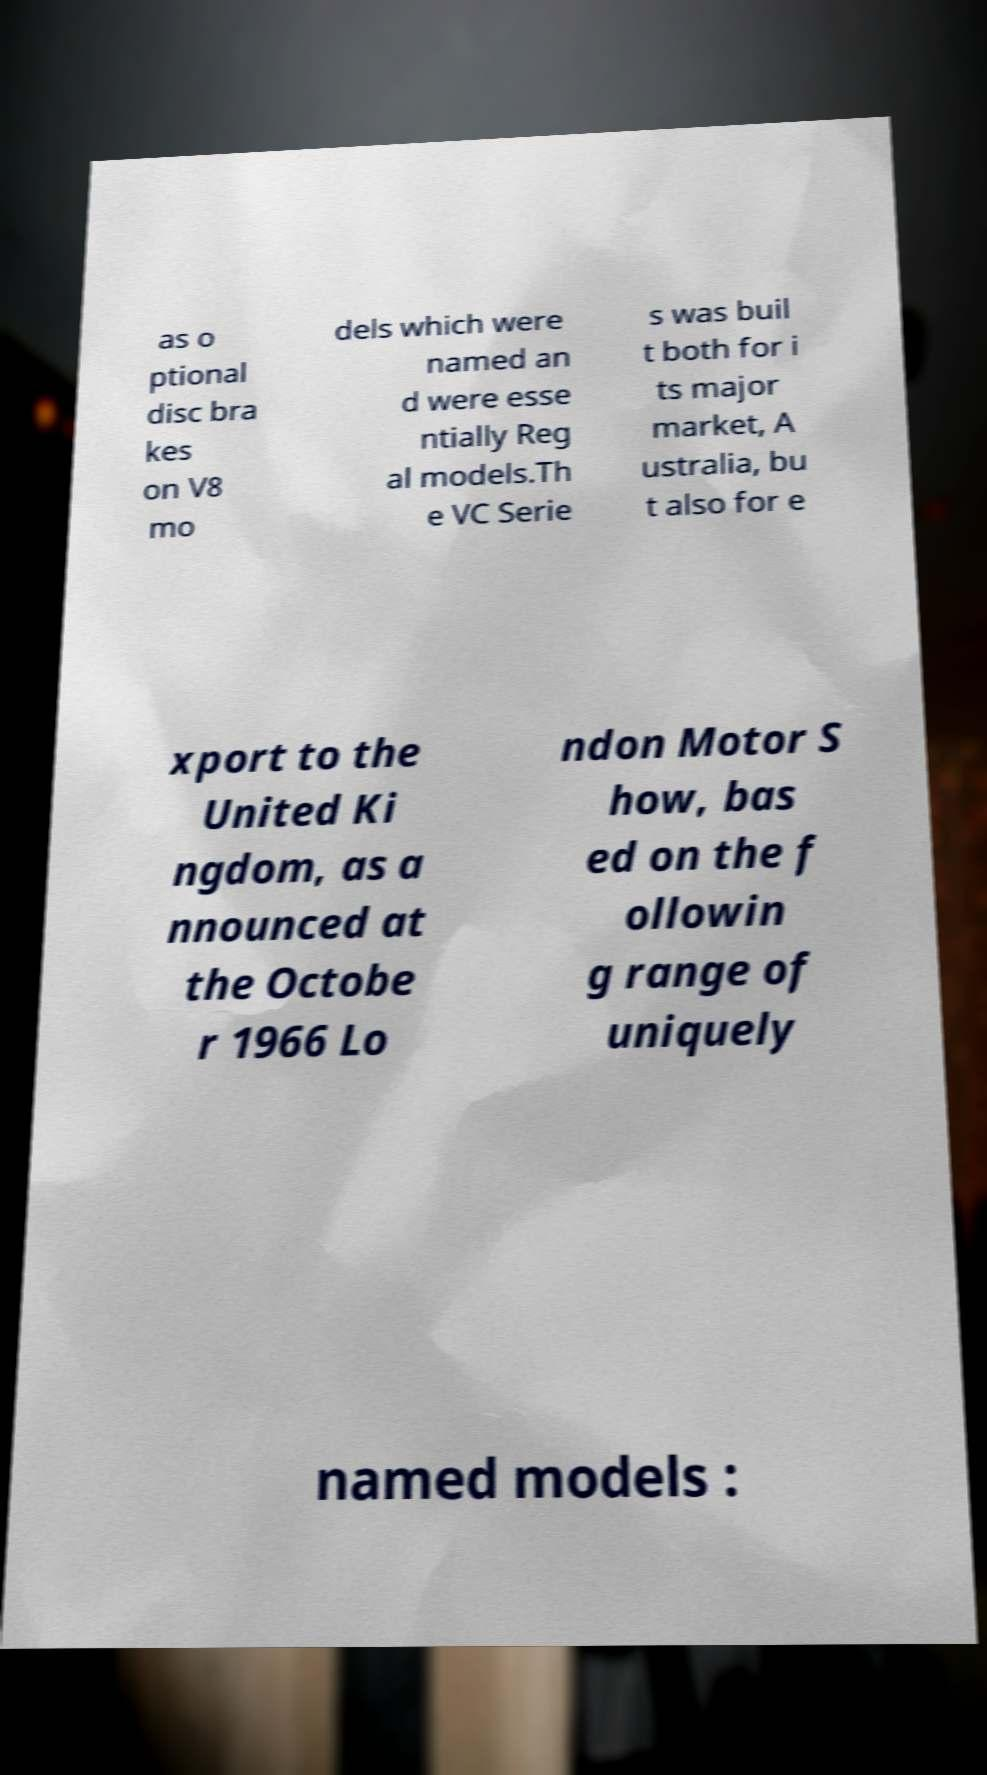Please read and relay the text visible in this image. What does it say? as o ptional disc bra kes on V8 mo dels which were named an d were esse ntially Reg al models.Th e VC Serie s was buil t both for i ts major market, A ustralia, bu t also for e xport to the United Ki ngdom, as a nnounced at the Octobe r 1966 Lo ndon Motor S how, bas ed on the f ollowin g range of uniquely named models : 